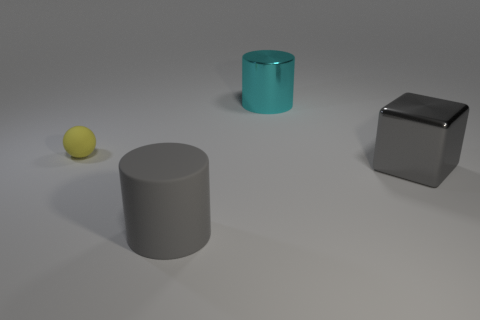Add 4 large cyan shiny cylinders. How many objects exist? 8 Subtract all purple metal cylinders. Subtract all yellow objects. How many objects are left? 3 Add 1 big matte cylinders. How many big matte cylinders are left? 2 Add 1 gray shiny cubes. How many gray shiny cubes exist? 2 Subtract 0 purple cubes. How many objects are left? 4 